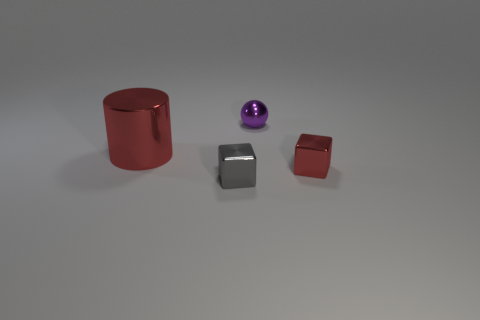What number of other things are the same color as the tiny ball?
Keep it short and to the point. 0. Are there fewer gray objects that are behind the tiny gray metal thing than small cubes that are to the right of the small purple object?
Keep it short and to the point. Yes. What number of objects are either red things that are left of the tiny shiny ball or cyan metal objects?
Your response must be concise. 1. Does the purple metallic ball have the same size as the red thing on the left side of the tiny purple ball?
Offer a very short reply. No. What size is the red metallic object that is the same shape as the gray metal object?
Ensure brevity in your answer.  Small. There is a tiny shiny cube to the left of the small cube to the right of the tiny purple ball; what number of red cubes are right of it?
Keep it short and to the point. 1. What number of cylinders are either large purple rubber things or small red metallic objects?
Offer a very short reply. 0. The tiny metal cube that is on the left side of the red thing that is in front of the red metal thing that is left of the red metal block is what color?
Keep it short and to the point. Gray. What number of other objects are there of the same size as the metal cylinder?
Offer a very short reply. 0. Is there anything else that is the same shape as the tiny red object?
Make the answer very short. Yes. 